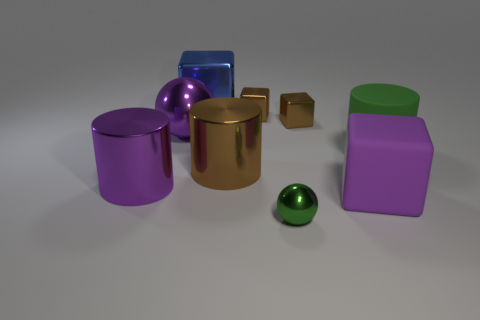Subtract all cyan cylinders. Subtract all purple cubes. How many cylinders are left? 3 Subtract all cylinders. How many objects are left? 6 Add 2 small brown metal cubes. How many small brown metal cubes are left? 4 Add 4 purple cylinders. How many purple cylinders exist? 5 Subtract 0 cyan cylinders. How many objects are left? 9 Subtract all large cyan blocks. Subtract all metal objects. How many objects are left? 2 